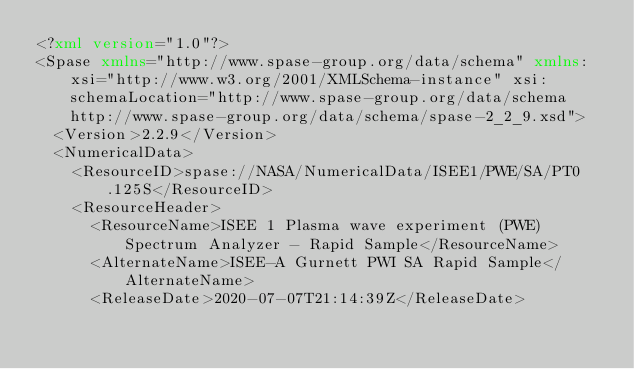<code> <loc_0><loc_0><loc_500><loc_500><_XML_><?xml version="1.0"?>
<Spase xmlns="http://www.spase-group.org/data/schema" xmlns:xsi="http://www.w3.org/2001/XMLSchema-instance" xsi:schemaLocation="http://www.spase-group.org/data/schema http://www.spase-group.org/data/schema/spase-2_2_9.xsd">
  <Version>2.2.9</Version>
  <NumericalData>
    <ResourceID>spase://NASA/NumericalData/ISEE1/PWE/SA/PT0.125S</ResourceID>
    <ResourceHeader>
      <ResourceName>ISEE 1 Plasma wave experiment (PWE) Spectrum Analyzer - Rapid Sample</ResourceName>
      <AlternateName>ISEE-A Gurnett PWI SA Rapid Sample</AlternateName>
      <ReleaseDate>2020-07-07T21:14:39Z</ReleaseDate></code> 